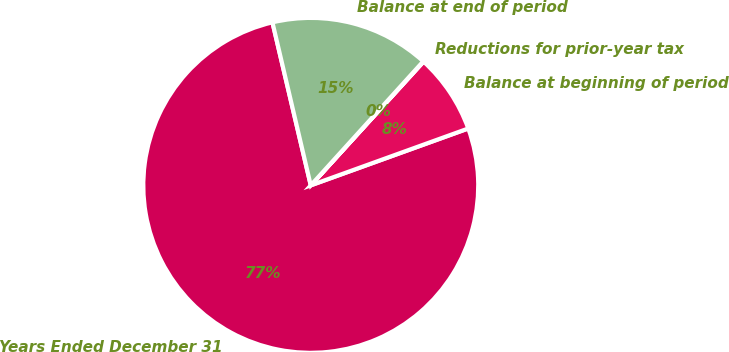Convert chart. <chart><loc_0><loc_0><loc_500><loc_500><pie_chart><fcel>Years Ended December 31<fcel>Balance at beginning of period<fcel>Reductions for prior-year tax<fcel>Balance at end of period<nl><fcel>76.84%<fcel>7.72%<fcel>0.04%<fcel>15.4%<nl></chart> 